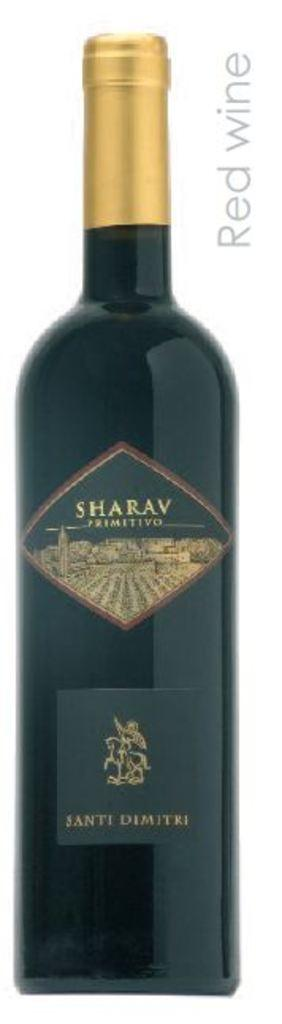Provide a one-sentence caption for the provided image. A long shot of a bottle of Santi Dimitri Red Wine. 